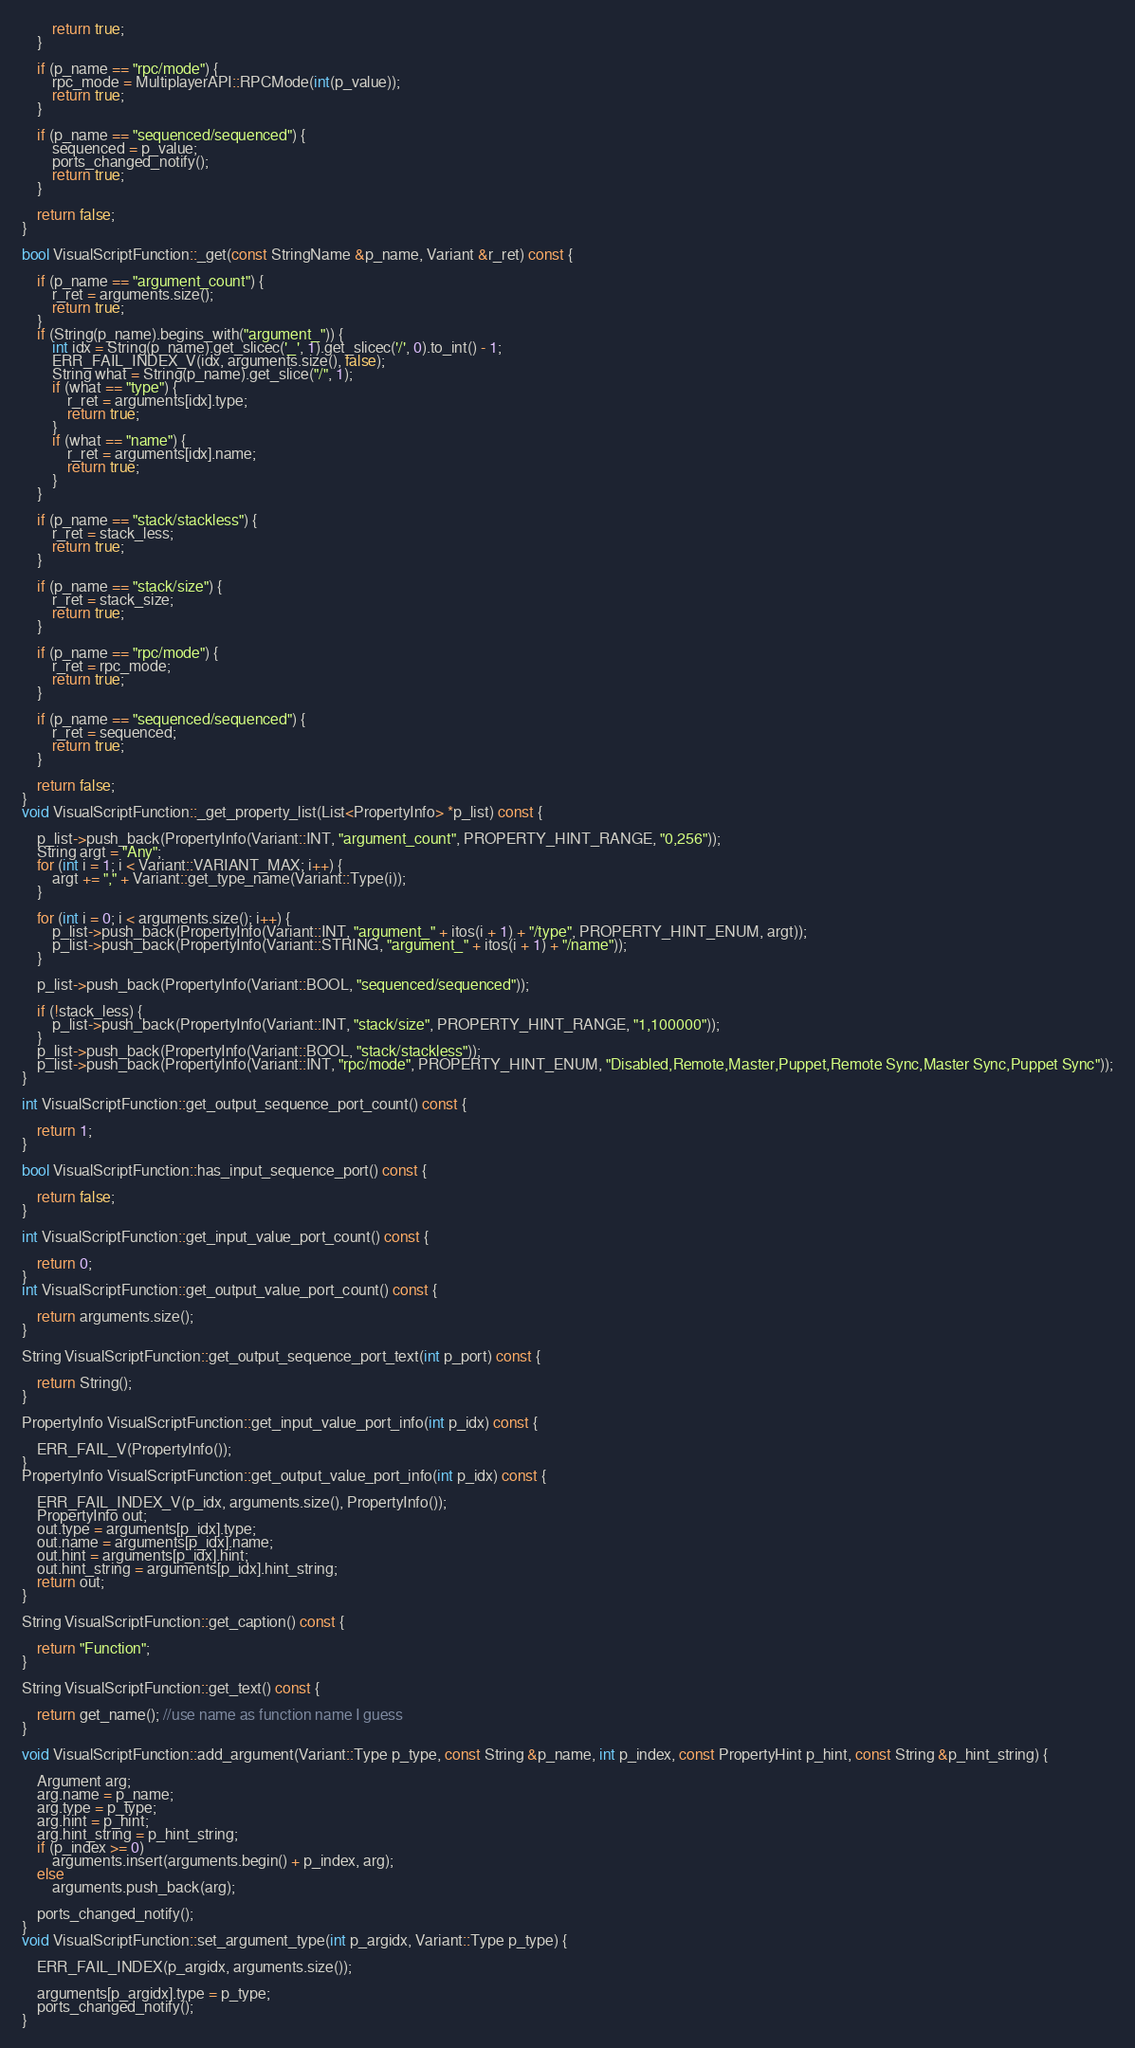<code> <loc_0><loc_0><loc_500><loc_500><_C++_>		return true;
	}

	if (p_name == "rpc/mode") {
		rpc_mode = MultiplayerAPI::RPCMode(int(p_value));
		return true;
	}

	if (p_name == "sequenced/sequenced") {
		sequenced = p_value;
		ports_changed_notify();
		return true;
	}

	return false;
}

bool VisualScriptFunction::_get(const StringName &p_name, Variant &r_ret) const {

	if (p_name == "argument_count") {
		r_ret = arguments.size();
		return true;
	}
	if (String(p_name).begins_with("argument_")) {
		int idx = String(p_name).get_slicec('_', 1).get_slicec('/', 0).to_int() - 1;
		ERR_FAIL_INDEX_V(idx, arguments.size(), false);
		String what = String(p_name).get_slice("/", 1);
		if (what == "type") {
			r_ret = arguments[idx].type;
			return true;
		}
		if (what == "name") {
			r_ret = arguments[idx].name;
			return true;
		}
	}

	if (p_name == "stack/stackless") {
		r_ret = stack_less;
		return true;
	}

	if (p_name == "stack/size") {
		r_ret = stack_size;
		return true;
	}

	if (p_name == "rpc/mode") {
		r_ret = rpc_mode;
		return true;
	}

	if (p_name == "sequenced/sequenced") {
		r_ret = sequenced;
		return true;
	}

	return false;
}
void VisualScriptFunction::_get_property_list(List<PropertyInfo> *p_list) const {

	p_list->push_back(PropertyInfo(Variant::INT, "argument_count", PROPERTY_HINT_RANGE, "0,256"));
	String argt = "Any";
	for (int i = 1; i < Variant::VARIANT_MAX; i++) {
		argt += "," + Variant::get_type_name(Variant::Type(i));
	}

	for (int i = 0; i < arguments.size(); i++) {
		p_list->push_back(PropertyInfo(Variant::INT, "argument_" + itos(i + 1) + "/type", PROPERTY_HINT_ENUM, argt));
		p_list->push_back(PropertyInfo(Variant::STRING, "argument_" + itos(i + 1) + "/name"));
	}

	p_list->push_back(PropertyInfo(Variant::BOOL, "sequenced/sequenced"));

	if (!stack_less) {
		p_list->push_back(PropertyInfo(Variant::INT, "stack/size", PROPERTY_HINT_RANGE, "1,100000"));
	}
	p_list->push_back(PropertyInfo(Variant::BOOL, "stack/stackless"));
	p_list->push_back(PropertyInfo(Variant::INT, "rpc/mode", PROPERTY_HINT_ENUM, "Disabled,Remote,Master,Puppet,Remote Sync,Master Sync,Puppet Sync"));
}

int VisualScriptFunction::get_output_sequence_port_count() const {

	return 1;
}

bool VisualScriptFunction::has_input_sequence_port() const {

	return false;
}

int VisualScriptFunction::get_input_value_port_count() const {

	return 0;
}
int VisualScriptFunction::get_output_value_port_count() const {

	return arguments.size();
}

String VisualScriptFunction::get_output_sequence_port_text(int p_port) const {

	return String();
}

PropertyInfo VisualScriptFunction::get_input_value_port_info(int p_idx) const {

	ERR_FAIL_V(PropertyInfo());
}
PropertyInfo VisualScriptFunction::get_output_value_port_info(int p_idx) const {

	ERR_FAIL_INDEX_V(p_idx, arguments.size(), PropertyInfo());
	PropertyInfo out;
	out.type = arguments[p_idx].type;
	out.name = arguments[p_idx].name;
	out.hint = arguments[p_idx].hint;
	out.hint_string = arguments[p_idx].hint_string;
	return out;
}

String VisualScriptFunction::get_caption() const {

	return "Function";
}

String VisualScriptFunction::get_text() const {

	return get_name(); //use name as function name I guess
}

void VisualScriptFunction::add_argument(Variant::Type p_type, const String &p_name, int p_index, const PropertyHint p_hint, const String &p_hint_string) {

	Argument arg;
	arg.name = p_name;
	arg.type = p_type;
	arg.hint = p_hint;
	arg.hint_string = p_hint_string;
	if (p_index >= 0)
		arguments.insert(arguments.begin() + p_index, arg);
	else
		arguments.push_back(arg);

	ports_changed_notify();
}
void VisualScriptFunction::set_argument_type(int p_argidx, Variant::Type p_type) {

	ERR_FAIL_INDEX(p_argidx, arguments.size());

	arguments[p_argidx].type = p_type;
	ports_changed_notify();
}</code> 